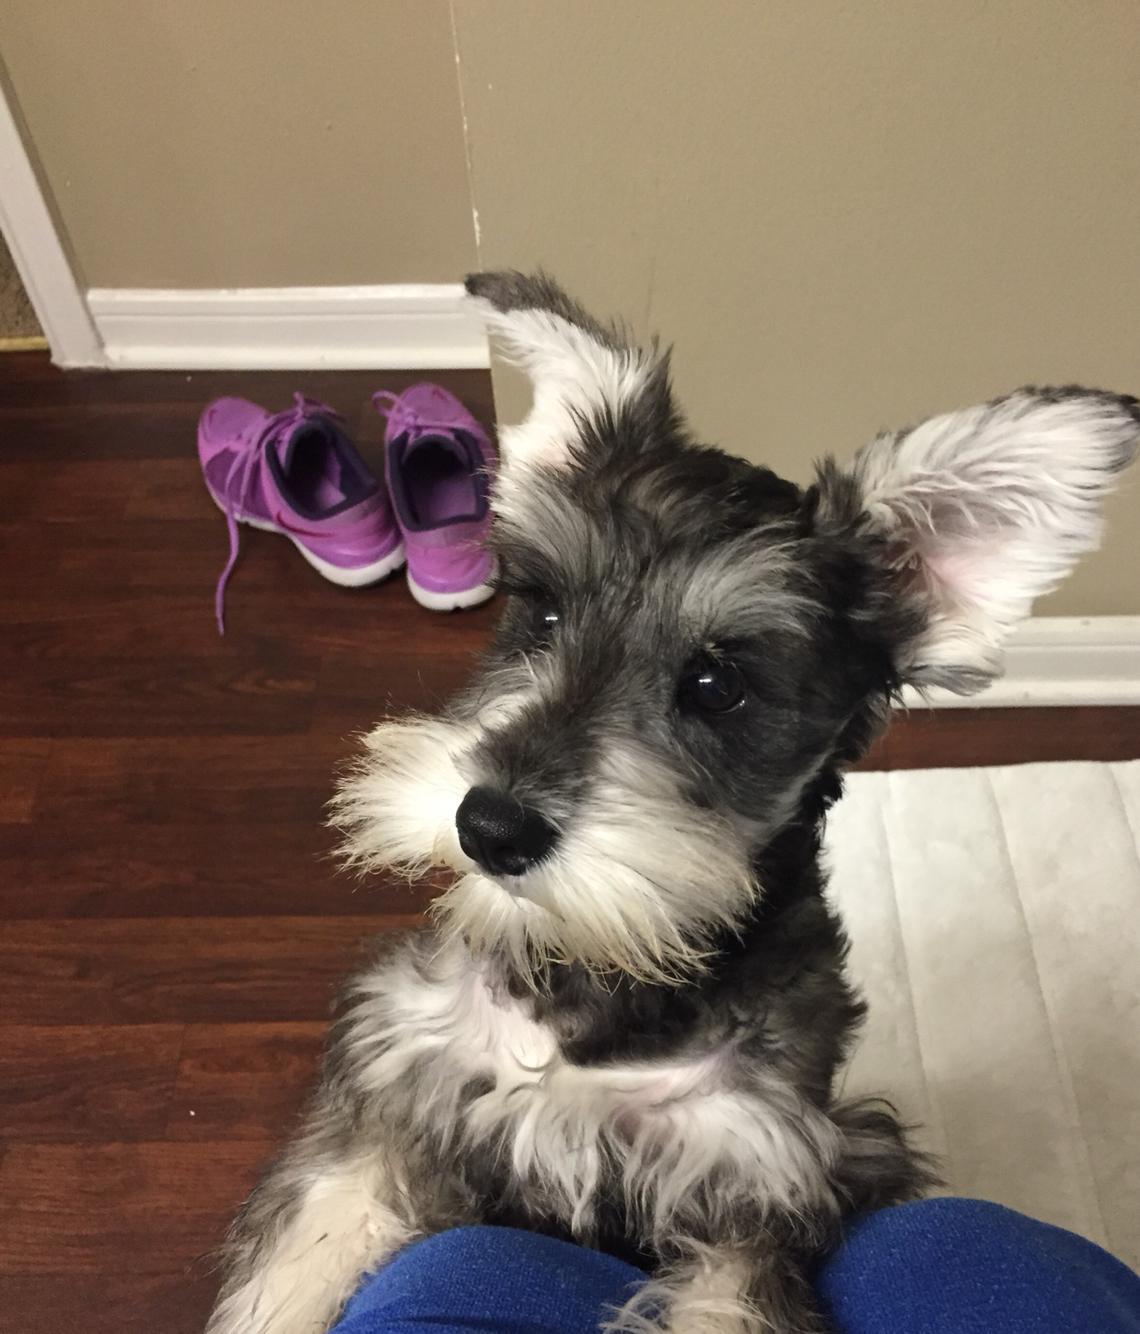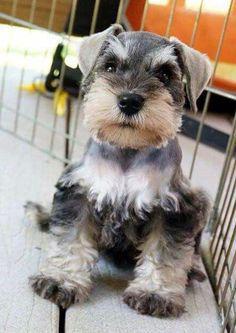The first image is the image on the left, the second image is the image on the right. Considering the images on both sides, is "There are exactly two dogs." valid? Answer yes or no. Yes. 